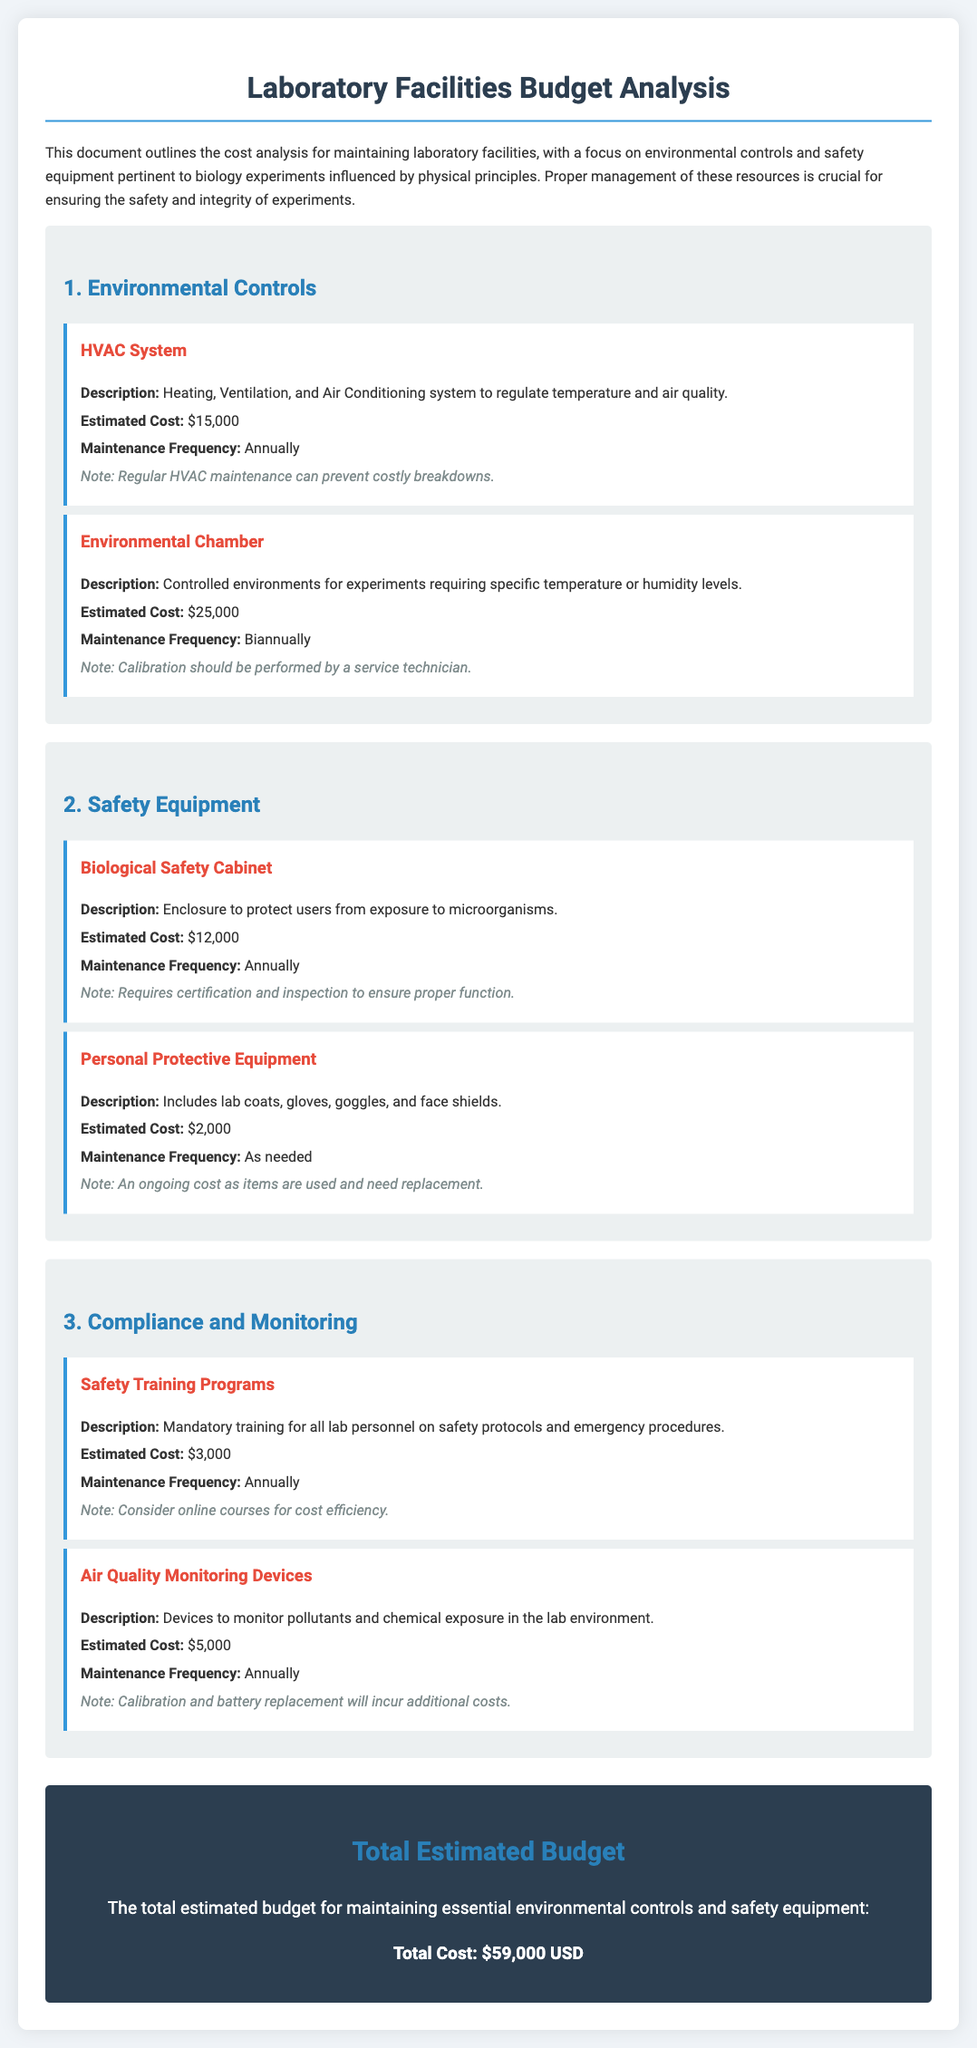what is the estimated cost of the HVAC System? The estimated cost for the HVAC System is listed in the document as $15,000.
Answer: $15,000 how often is the Environmental Chamber maintained? The maintenance frequency for the Environmental Chamber is biannually as mentioned in the document.
Answer: Biannually what type of equipment requires certification and inspection? The Biological Safety Cabinet is specifically noted to require certification and inspection to ensure proper function.
Answer: Biological Safety Cabinet what is the total estimated budget for maintaining essential facilities? The total estimated budget provided in the document for maintaining the essential facilities is $59,000.
Answer: $59,000 what is included in the Personal Protective Equipment category? The Personal Protective Equipment includes lab coats, gloves, goggles, and face shields as detailed in the document.
Answer: lab coats, gloves, goggles, and face shields why should regular HVAC maintenance be performed? Regular HVAC maintenance can prevent costly breakdowns, indicating its importance for operational effectiveness.
Answer: prevent costly breakdowns what is the estimated cost for Safety Training Programs? The estimated cost for Safety Training Programs is mentioned as $3,000 in the budget analysis.
Answer: $3,000 how often should Air Quality Monitoring Devices be maintained? The document states that Air Quality Monitoring Devices should be maintained annually.
Answer: Annually 